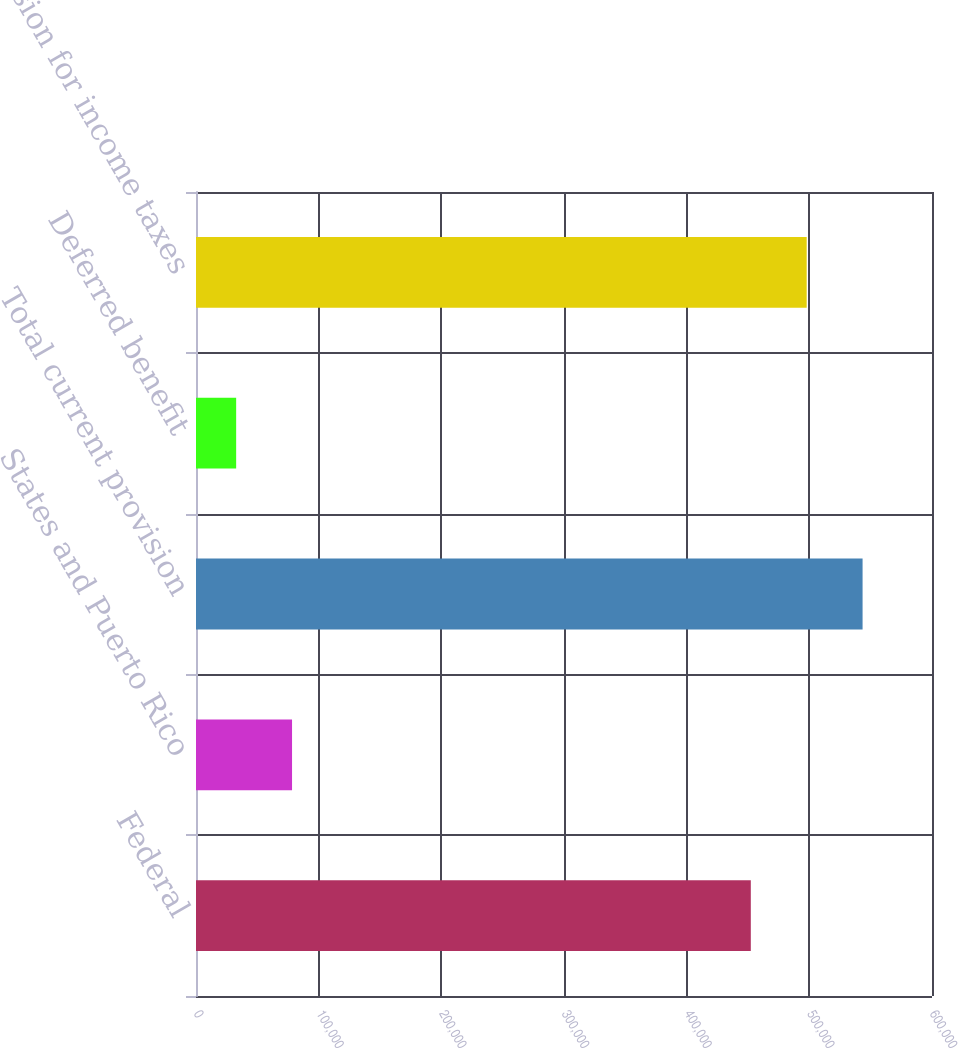<chart> <loc_0><loc_0><loc_500><loc_500><bar_chart><fcel>Federal<fcel>States and Puerto Rico<fcel>Total current provision<fcel>Deferred benefit<fcel>Provision for income taxes<nl><fcel>452286<fcel>78297.6<fcel>543409<fcel>32736<fcel>497848<nl></chart> 